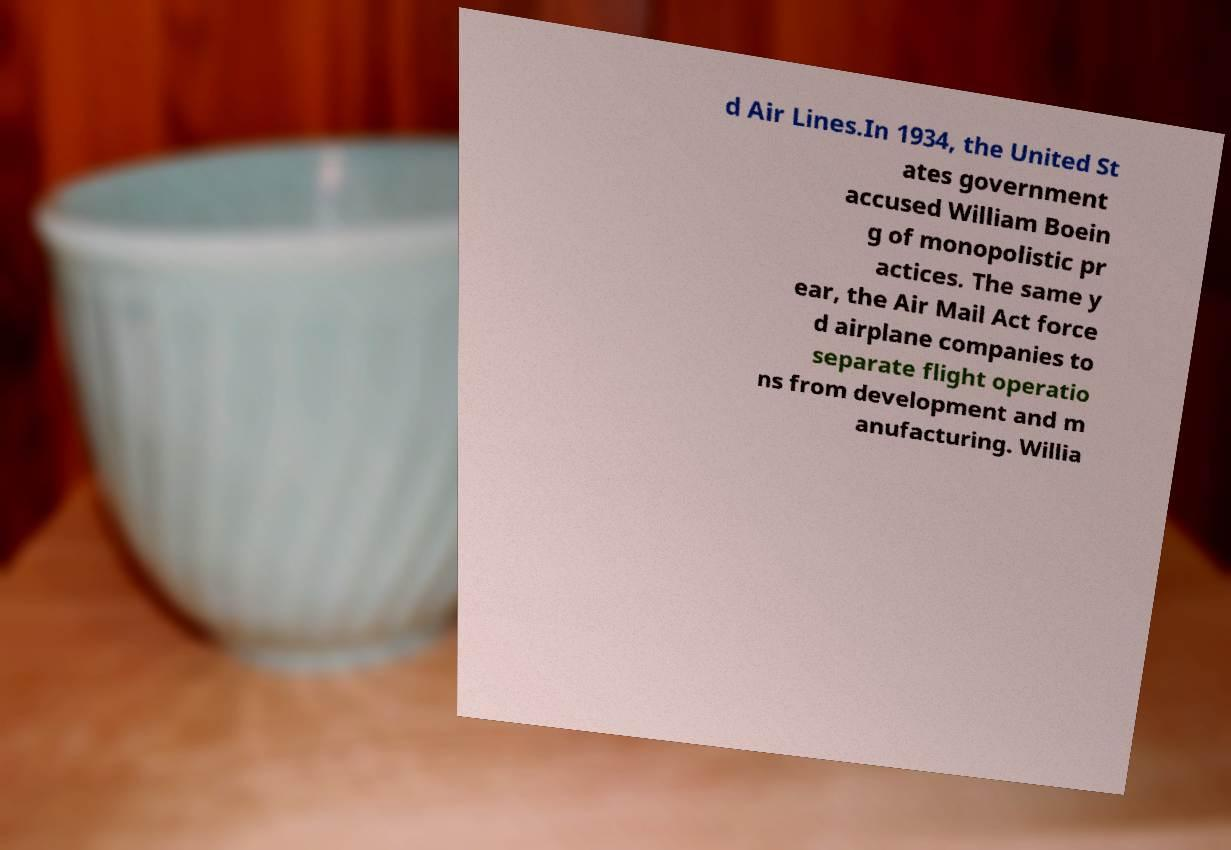Can you read and provide the text displayed in the image?This photo seems to have some interesting text. Can you extract and type it out for me? d Air Lines.In 1934, the United St ates government accused William Boein g of monopolistic pr actices. The same y ear, the Air Mail Act force d airplane companies to separate flight operatio ns from development and m anufacturing. Willia 